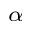Convert formula to latex. <formula><loc_0><loc_0><loc_500><loc_500>_ { \alpha }</formula> 